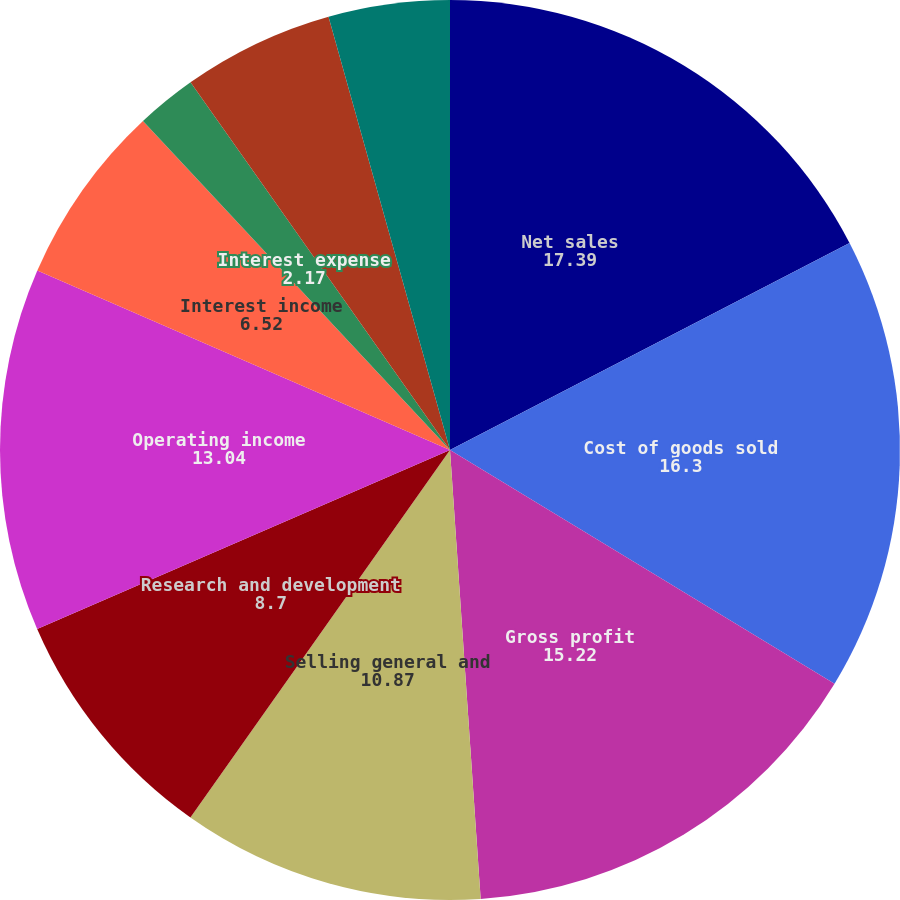Convert chart. <chart><loc_0><loc_0><loc_500><loc_500><pie_chart><fcel>Net sales<fcel>Cost of goods sold<fcel>Gross profit<fcel>Selling general and<fcel>Research and development<fcel>Operating income<fcel>Interest income<fcel>Interest expense<fcel>Foreign currency<fcel>Gain on sale of equity<nl><fcel>17.39%<fcel>16.3%<fcel>15.22%<fcel>10.87%<fcel>8.7%<fcel>13.04%<fcel>6.52%<fcel>2.17%<fcel>5.43%<fcel>4.35%<nl></chart> 